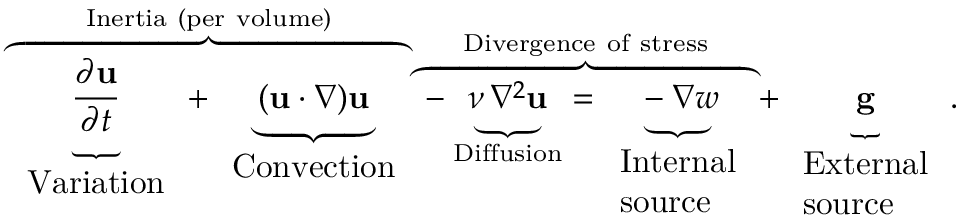Convert formula to latex. <formula><loc_0><loc_0><loc_500><loc_500>\overbrace { \underbrace { \frac { \partial u } { \partial t } } _ { \begin{array} { l } { V a r i a t i o n } \end{array} } + \underbrace { ( u \cdot \nabla ) u } _ { \begin{array} { l } { C o n v e c t i o n } \end{array} } } ^ { I n e r t i a ( p e r v o l u m e ) } \overbrace { - \underbrace { \nu \, \nabla ^ { 2 } u } _ { D i f f u s i o n } = \underbrace { - \nabla w } _ { \begin{array} { l } { I n t e r n a l } \\ { s o u r c e } \end{array} } } ^ { D i v e r g e n c e o f s t r e s s } + \underbrace { g } _ { \begin{array} { l } { E x t e r n a l } \\ { s o u r c e } \end{array} } .</formula> 